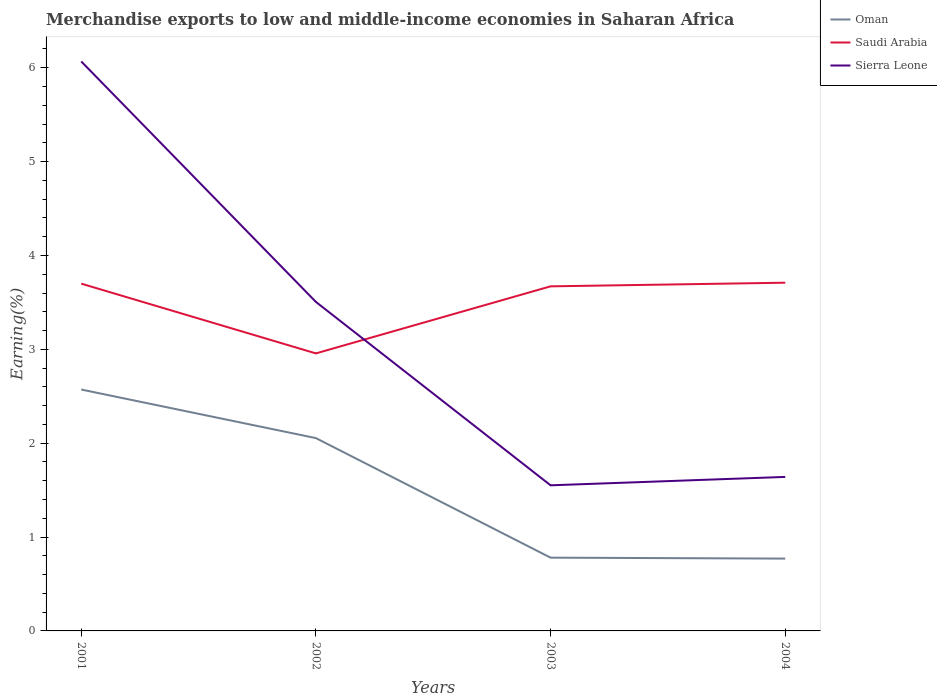Does the line corresponding to Oman intersect with the line corresponding to Sierra Leone?
Your answer should be compact. No. Across all years, what is the maximum percentage of amount earned from merchandise exports in Saudi Arabia?
Your answer should be compact. 2.96. In which year was the percentage of amount earned from merchandise exports in Saudi Arabia maximum?
Your response must be concise. 2002. What is the total percentage of amount earned from merchandise exports in Sierra Leone in the graph?
Ensure brevity in your answer.  4.52. What is the difference between the highest and the second highest percentage of amount earned from merchandise exports in Sierra Leone?
Provide a succinct answer. 4.52. What is the difference between the highest and the lowest percentage of amount earned from merchandise exports in Saudi Arabia?
Your response must be concise. 3. How many lines are there?
Provide a short and direct response. 3. Does the graph contain any zero values?
Your response must be concise. No. What is the title of the graph?
Provide a succinct answer. Merchandise exports to low and middle-income economies in Saharan Africa. Does "Belgium" appear as one of the legend labels in the graph?
Your answer should be compact. No. What is the label or title of the Y-axis?
Your answer should be compact. Earning(%). What is the Earning(%) in Oman in 2001?
Provide a succinct answer. 2.57. What is the Earning(%) of Saudi Arabia in 2001?
Give a very brief answer. 3.7. What is the Earning(%) of Sierra Leone in 2001?
Your response must be concise. 6.07. What is the Earning(%) of Oman in 2002?
Your answer should be very brief. 2.05. What is the Earning(%) in Saudi Arabia in 2002?
Provide a short and direct response. 2.96. What is the Earning(%) in Sierra Leone in 2002?
Your answer should be very brief. 3.51. What is the Earning(%) in Oman in 2003?
Give a very brief answer. 0.78. What is the Earning(%) of Saudi Arabia in 2003?
Your response must be concise. 3.67. What is the Earning(%) of Sierra Leone in 2003?
Provide a succinct answer. 1.55. What is the Earning(%) of Oman in 2004?
Your answer should be compact. 0.77. What is the Earning(%) in Saudi Arabia in 2004?
Offer a very short reply. 3.71. What is the Earning(%) in Sierra Leone in 2004?
Give a very brief answer. 1.64. Across all years, what is the maximum Earning(%) of Oman?
Make the answer very short. 2.57. Across all years, what is the maximum Earning(%) in Saudi Arabia?
Make the answer very short. 3.71. Across all years, what is the maximum Earning(%) of Sierra Leone?
Provide a short and direct response. 6.07. Across all years, what is the minimum Earning(%) in Oman?
Provide a succinct answer. 0.77. Across all years, what is the minimum Earning(%) in Saudi Arabia?
Your answer should be very brief. 2.96. Across all years, what is the minimum Earning(%) in Sierra Leone?
Make the answer very short. 1.55. What is the total Earning(%) in Oman in the graph?
Make the answer very short. 6.18. What is the total Earning(%) in Saudi Arabia in the graph?
Your answer should be compact. 14.04. What is the total Earning(%) in Sierra Leone in the graph?
Offer a very short reply. 12.77. What is the difference between the Earning(%) of Oman in 2001 and that in 2002?
Offer a terse response. 0.52. What is the difference between the Earning(%) in Saudi Arabia in 2001 and that in 2002?
Your response must be concise. 0.74. What is the difference between the Earning(%) in Sierra Leone in 2001 and that in 2002?
Make the answer very short. 2.56. What is the difference between the Earning(%) of Oman in 2001 and that in 2003?
Offer a very short reply. 1.79. What is the difference between the Earning(%) in Saudi Arabia in 2001 and that in 2003?
Your answer should be compact. 0.03. What is the difference between the Earning(%) of Sierra Leone in 2001 and that in 2003?
Ensure brevity in your answer.  4.52. What is the difference between the Earning(%) in Oman in 2001 and that in 2004?
Your answer should be very brief. 1.8. What is the difference between the Earning(%) of Saudi Arabia in 2001 and that in 2004?
Make the answer very short. -0.01. What is the difference between the Earning(%) of Sierra Leone in 2001 and that in 2004?
Make the answer very short. 4.43. What is the difference between the Earning(%) in Oman in 2002 and that in 2003?
Provide a succinct answer. 1.27. What is the difference between the Earning(%) of Saudi Arabia in 2002 and that in 2003?
Provide a short and direct response. -0.71. What is the difference between the Earning(%) of Sierra Leone in 2002 and that in 2003?
Offer a terse response. 1.95. What is the difference between the Earning(%) of Oman in 2002 and that in 2004?
Your answer should be compact. 1.28. What is the difference between the Earning(%) in Saudi Arabia in 2002 and that in 2004?
Provide a succinct answer. -0.75. What is the difference between the Earning(%) in Sierra Leone in 2002 and that in 2004?
Provide a succinct answer. 1.86. What is the difference between the Earning(%) in Oman in 2003 and that in 2004?
Ensure brevity in your answer.  0.01. What is the difference between the Earning(%) of Saudi Arabia in 2003 and that in 2004?
Give a very brief answer. -0.04. What is the difference between the Earning(%) of Sierra Leone in 2003 and that in 2004?
Keep it short and to the point. -0.09. What is the difference between the Earning(%) in Oman in 2001 and the Earning(%) in Saudi Arabia in 2002?
Offer a very short reply. -0.39. What is the difference between the Earning(%) of Oman in 2001 and the Earning(%) of Sierra Leone in 2002?
Provide a short and direct response. -0.93. What is the difference between the Earning(%) of Saudi Arabia in 2001 and the Earning(%) of Sierra Leone in 2002?
Offer a terse response. 0.19. What is the difference between the Earning(%) of Oman in 2001 and the Earning(%) of Saudi Arabia in 2003?
Your answer should be compact. -1.1. What is the difference between the Earning(%) of Oman in 2001 and the Earning(%) of Sierra Leone in 2003?
Ensure brevity in your answer.  1.02. What is the difference between the Earning(%) in Saudi Arabia in 2001 and the Earning(%) in Sierra Leone in 2003?
Provide a succinct answer. 2.15. What is the difference between the Earning(%) in Oman in 2001 and the Earning(%) in Saudi Arabia in 2004?
Provide a short and direct response. -1.14. What is the difference between the Earning(%) of Saudi Arabia in 2001 and the Earning(%) of Sierra Leone in 2004?
Provide a short and direct response. 2.06. What is the difference between the Earning(%) in Oman in 2002 and the Earning(%) in Saudi Arabia in 2003?
Your answer should be compact. -1.62. What is the difference between the Earning(%) in Oman in 2002 and the Earning(%) in Sierra Leone in 2003?
Provide a succinct answer. 0.5. What is the difference between the Earning(%) in Saudi Arabia in 2002 and the Earning(%) in Sierra Leone in 2003?
Your answer should be very brief. 1.41. What is the difference between the Earning(%) of Oman in 2002 and the Earning(%) of Saudi Arabia in 2004?
Your response must be concise. -1.66. What is the difference between the Earning(%) of Oman in 2002 and the Earning(%) of Sierra Leone in 2004?
Your answer should be very brief. 0.41. What is the difference between the Earning(%) in Saudi Arabia in 2002 and the Earning(%) in Sierra Leone in 2004?
Make the answer very short. 1.32. What is the difference between the Earning(%) in Oman in 2003 and the Earning(%) in Saudi Arabia in 2004?
Make the answer very short. -2.93. What is the difference between the Earning(%) in Oman in 2003 and the Earning(%) in Sierra Leone in 2004?
Offer a very short reply. -0.86. What is the difference between the Earning(%) of Saudi Arabia in 2003 and the Earning(%) of Sierra Leone in 2004?
Ensure brevity in your answer.  2.03. What is the average Earning(%) in Oman per year?
Make the answer very short. 1.54. What is the average Earning(%) in Saudi Arabia per year?
Give a very brief answer. 3.51. What is the average Earning(%) of Sierra Leone per year?
Offer a terse response. 3.19. In the year 2001, what is the difference between the Earning(%) of Oman and Earning(%) of Saudi Arabia?
Make the answer very short. -1.13. In the year 2001, what is the difference between the Earning(%) of Oman and Earning(%) of Sierra Leone?
Your answer should be very brief. -3.5. In the year 2001, what is the difference between the Earning(%) in Saudi Arabia and Earning(%) in Sierra Leone?
Provide a short and direct response. -2.37. In the year 2002, what is the difference between the Earning(%) of Oman and Earning(%) of Saudi Arabia?
Make the answer very short. -0.9. In the year 2002, what is the difference between the Earning(%) in Oman and Earning(%) in Sierra Leone?
Your answer should be compact. -1.45. In the year 2002, what is the difference between the Earning(%) in Saudi Arabia and Earning(%) in Sierra Leone?
Provide a succinct answer. -0.55. In the year 2003, what is the difference between the Earning(%) in Oman and Earning(%) in Saudi Arabia?
Offer a very short reply. -2.89. In the year 2003, what is the difference between the Earning(%) of Oman and Earning(%) of Sierra Leone?
Provide a succinct answer. -0.77. In the year 2003, what is the difference between the Earning(%) of Saudi Arabia and Earning(%) of Sierra Leone?
Offer a very short reply. 2.12. In the year 2004, what is the difference between the Earning(%) in Oman and Earning(%) in Saudi Arabia?
Ensure brevity in your answer.  -2.94. In the year 2004, what is the difference between the Earning(%) in Oman and Earning(%) in Sierra Leone?
Offer a very short reply. -0.87. In the year 2004, what is the difference between the Earning(%) in Saudi Arabia and Earning(%) in Sierra Leone?
Give a very brief answer. 2.07. What is the ratio of the Earning(%) in Oman in 2001 to that in 2002?
Provide a succinct answer. 1.25. What is the ratio of the Earning(%) in Saudi Arabia in 2001 to that in 2002?
Provide a short and direct response. 1.25. What is the ratio of the Earning(%) in Sierra Leone in 2001 to that in 2002?
Keep it short and to the point. 1.73. What is the ratio of the Earning(%) of Oman in 2001 to that in 2003?
Offer a very short reply. 3.29. What is the ratio of the Earning(%) in Saudi Arabia in 2001 to that in 2003?
Provide a short and direct response. 1.01. What is the ratio of the Earning(%) of Sierra Leone in 2001 to that in 2003?
Your response must be concise. 3.91. What is the ratio of the Earning(%) in Oman in 2001 to that in 2004?
Provide a short and direct response. 3.34. What is the ratio of the Earning(%) of Sierra Leone in 2001 to that in 2004?
Your answer should be compact. 3.7. What is the ratio of the Earning(%) of Oman in 2002 to that in 2003?
Offer a terse response. 2.63. What is the ratio of the Earning(%) of Saudi Arabia in 2002 to that in 2003?
Keep it short and to the point. 0.81. What is the ratio of the Earning(%) of Sierra Leone in 2002 to that in 2003?
Your response must be concise. 2.26. What is the ratio of the Earning(%) of Oman in 2002 to that in 2004?
Give a very brief answer. 2.67. What is the ratio of the Earning(%) in Saudi Arabia in 2002 to that in 2004?
Keep it short and to the point. 0.8. What is the ratio of the Earning(%) in Sierra Leone in 2002 to that in 2004?
Offer a terse response. 2.14. What is the ratio of the Earning(%) in Oman in 2003 to that in 2004?
Provide a short and direct response. 1.01. What is the ratio of the Earning(%) of Sierra Leone in 2003 to that in 2004?
Your answer should be very brief. 0.95. What is the difference between the highest and the second highest Earning(%) in Oman?
Provide a succinct answer. 0.52. What is the difference between the highest and the second highest Earning(%) of Saudi Arabia?
Keep it short and to the point. 0.01. What is the difference between the highest and the second highest Earning(%) of Sierra Leone?
Give a very brief answer. 2.56. What is the difference between the highest and the lowest Earning(%) of Oman?
Your response must be concise. 1.8. What is the difference between the highest and the lowest Earning(%) of Saudi Arabia?
Offer a very short reply. 0.75. What is the difference between the highest and the lowest Earning(%) of Sierra Leone?
Your answer should be compact. 4.52. 